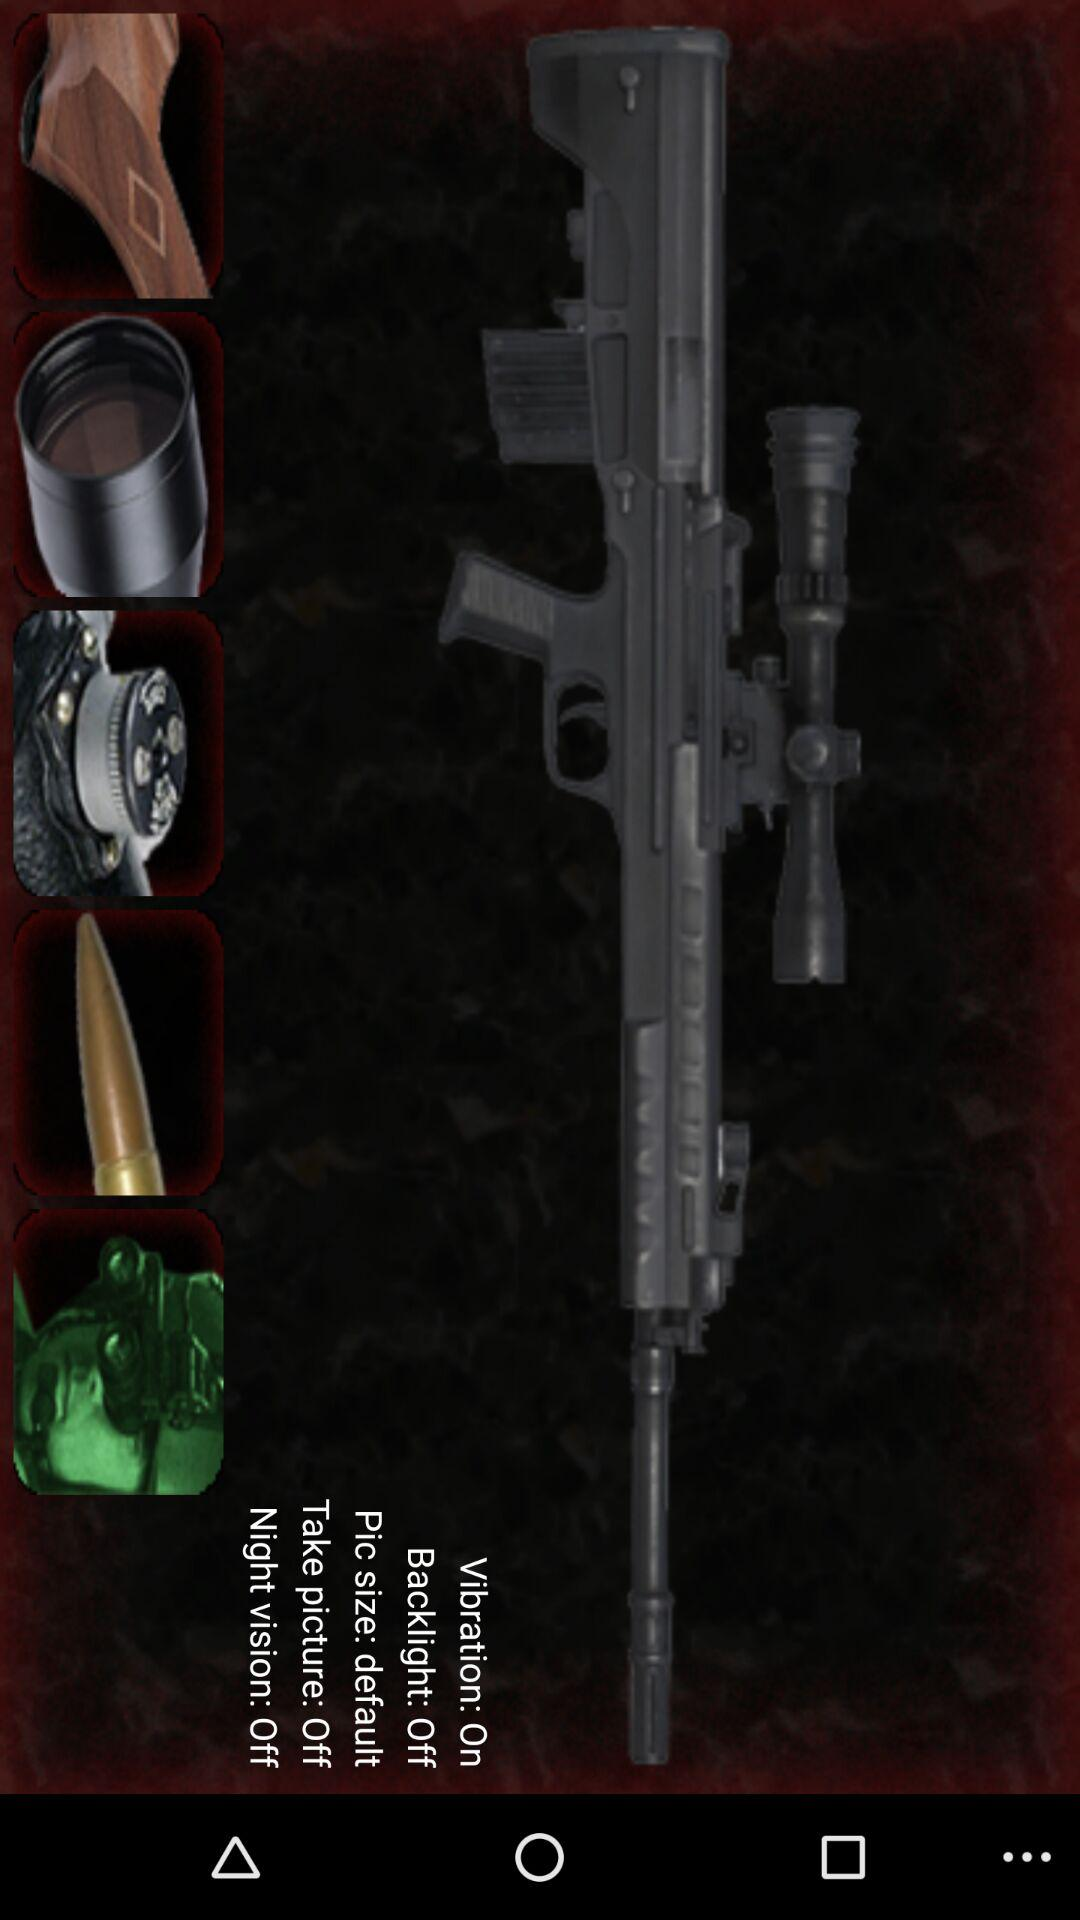What is the size of the picture? The size of the picture is "default". 